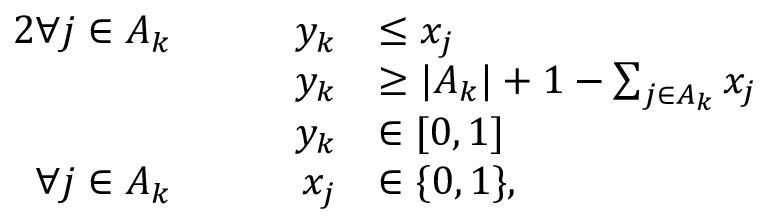<formula> <loc_0><loc_0><loc_500><loc_500>\begin{array} { r l r l } { { 2 } \forall j \in A _ { k } } & { \quad y _ { k } } & { \leq x _ { j } } \\ & { \quad y _ { k } } & { \geq | A _ { k } | + 1 - \sum _ { j \in A _ { k } } x _ { j } } \\ & { \quad y _ { k } } & { \in [ 0 , 1 ] } \\ { \forall j \in A _ { k } } & { \quad x _ { j } } & { \in \{ 0 , 1 \} , } \end{array}</formula> 